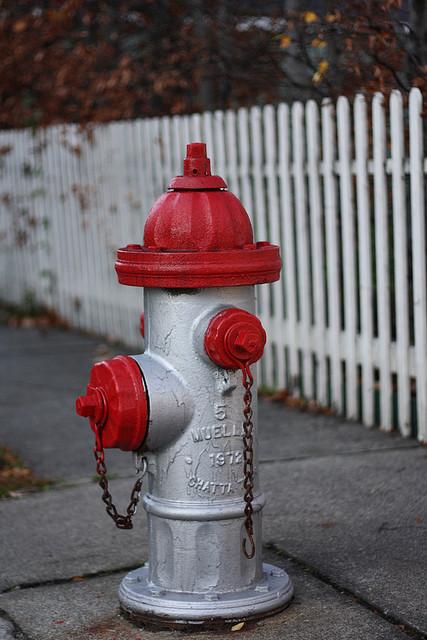Is the top of the fire hydrant a traditional fire hydrant color?
Write a very short answer. Yes. Does the hydrant look like a robot?
Keep it brief. No. Is the shadow of the hydrant visible?
Concise answer only. No. What are the metal things hanging of the fire hydrant?
Write a very short answer. Chains. What color is the fence?
Write a very short answer. White. What color is the hydrant?
Write a very short answer. Silver and red. Is the fire hydrant located in the middle of the cement block?
Keep it brief. Yes. Is there any graffiti on the hydrant?
Answer briefly. No. What is the color on the top of the hydrant?
Answer briefly. Red. 